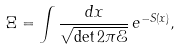<formula> <loc_0><loc_0><loc_500><loc_500>\Xi = \int \frac { d { x } } { \sqrt { \det { 2 \pi \mathcal { E } } } } \, e ^ { - S ( { x } ) } ,</formula> 